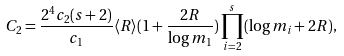Convert formula to latex. <formula><loc_0><loc_0><loc_500><loc_500>C _ { 2 } = \frac { 2 ^ { 4 } c _ { 2 } ( s + 2 ) } { c _ { 1 } } \langle R \rangle ( 1 + \frac { 2 R } { \log m _ { 1 } } ) \prod _ { i = 2 } ^ { s } ( \log m _ { i } + 2 R ) ,</formula> 